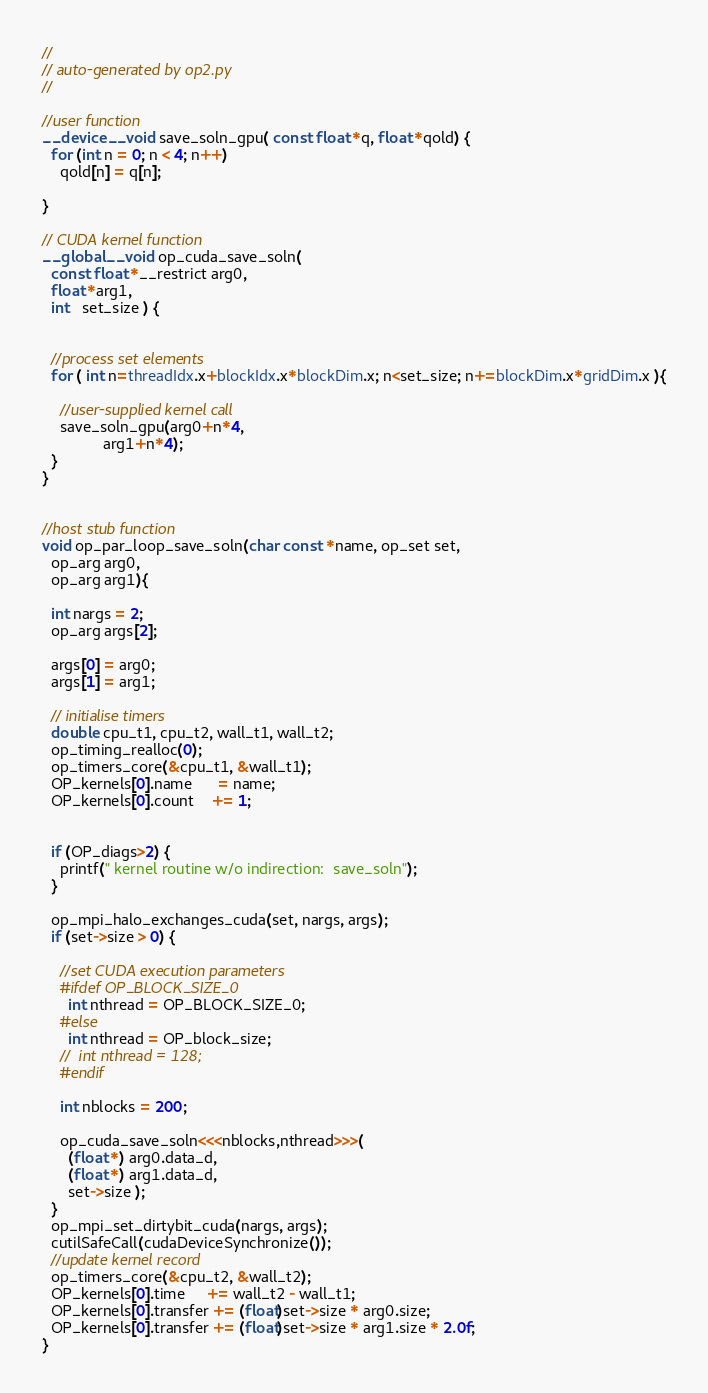<code> <loc_0><loc_0><loc_500><loc_500><_Cuda_>//
// auto-generated by op2.py
//

//user function
__device__ void save_soln_gpu( const float *q, float *qold) {
  for (int n = 0; n < 4; n++)
    qold[n] = q[n];

}

// CUDA kernel function
__global__ void op_cuda_save_soln(
  const float *__restrict arg0,
  float *arg1,
  int   set_size ) {


  //process set elements
  for ( int n=threadIdx.x+blockIdx.x*blockDim.x; n<set_size; n+=blockDim.x*gridDim.x ){

    //user-supplied kernel call
    save_soln_gpu(arg0+n*4,
              arg1+n*4);
  }
}


//host stub function
void op_par_loop_save_soln(char const *name, op_set set,
  op_arg arg0,
  op_arg arg1){

  int nargs = 2;
  op_arg args[2];

  args[0] = arg0;
  args[1] = arg1;

  // initialise timers
  double cpu_t1, cpu_t2, wall_t1, wall_t2;
  op_timing_realloc(0);
  op_timers_core(&cpu_t1, &wall_t1);
  OP_kernels[0].name      = name;
  OP_kernels[0].count    += 1;


  if (OP_diags>2) {
    printf(" kernel routine w/o indirection:  save_soln");
  }

  op_mpi_halo_exchanges_cuda(set, nargs, args);
  if (set->size > 0) {

    //set CUDA execution parameters
    #ifdef OP_BLOCK_SIZE_0
      int nthread = OP_BLOCK_SIZE_0;
    #else
      int nthread = OP_block_size;
    //  int nthread = 128;
    #endif

    int nblocks = 200;

    op_cuda_save_soln<<<nblocks,nthread>>>(
      (float *) arg0.data_d,
      (float *) arg1.data_d,
      set->size );
  }
  op_mpi_set_dirtybit_cuda(nargs, args);
  cutilSafeCall(cudaDeviceSynchronize());
  //update kernel record
  op_timers_core(&cpu_t2, &wall_t2);
  OP_kernels[0].time     += wall_t2 - wall_t1;
  OP_kernels[0].transfer += (float)set->size * arg0.size;
  OP_kernels[0].transfer += (float)set->size * arg1.size * 2.0f;
}
</code> 